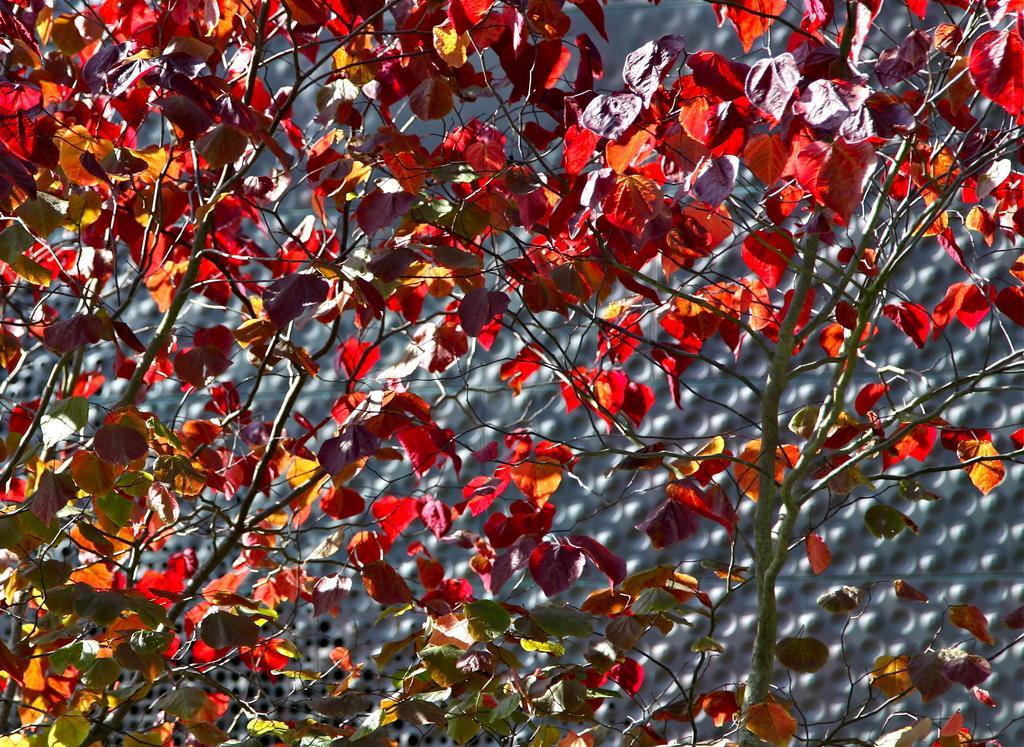In one or two sentences, can you explain what this image depicts? In the foreground of this image, there are leaves to the trees. In the background, it seems like a mesh. 